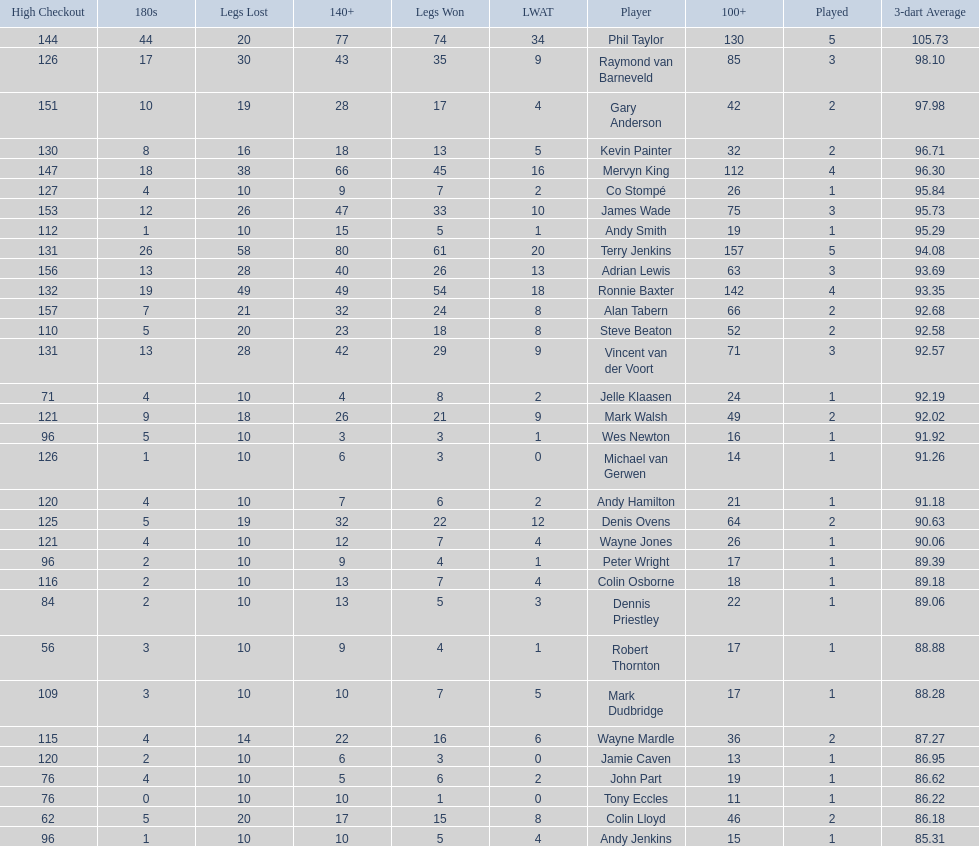Who won the highest number of legs in the 2009 world matchplay? Phil Taylor. 